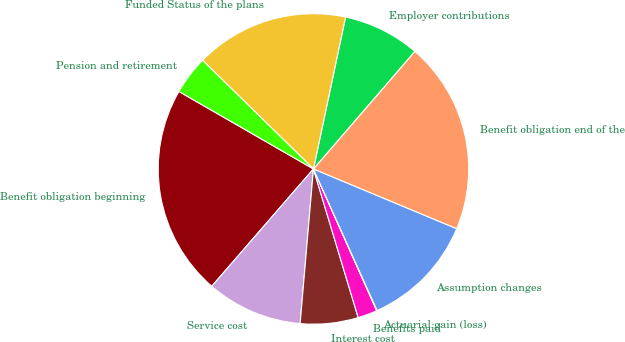Convert chart. <chart><loc_0><loc_0><loc_500><loc_500><pie_chart><fcel>Benefit obligation beginning<fcel>Service cost<fcel>Interest cost<fcel>Benefits paid<fcel>Actuarial gain (loss)<fcel>Assumption changes<fcel>Benefit obligation end of the<fcel>Employer contributions<fcel>Funded Status of the plans<fcel>Pension and retirement<nl><fcel>21.95%<fcel>10.0%<fcel>6.02%<fcel>2.03%<fcel>0.04%<fcel>11.99%<fcel>19.96%<fcel>8.01%<fcel>15.98%<fcel>4.02%<nl></chart> 